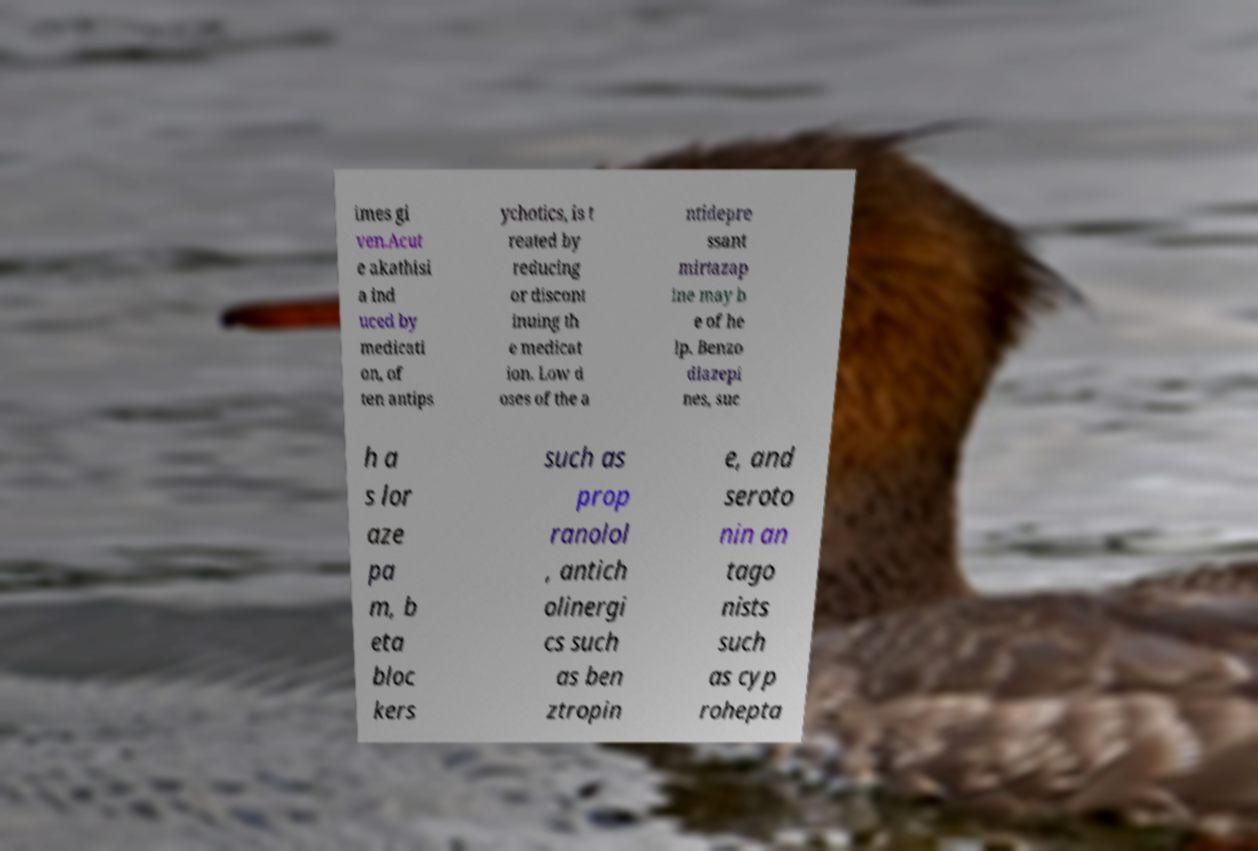What messages or text are displayed in this image? I need them in a readable, typed format. imes gi ven.Acut e akathisi a ind uced by medicati on, of ten antips ychotics, is t reated by reducing or discont inuing th e medicat ion. Low d oses of the a ntidepre ssant mirtazap ine may b e of he lp. Benzo diazepi nes, suc h a s lor aze pa m, b eta bloc kers such as prop ranolol , antich olinergi cs such as ben ztropin e, and seroto nin an tago nists such as cyp rohepta 